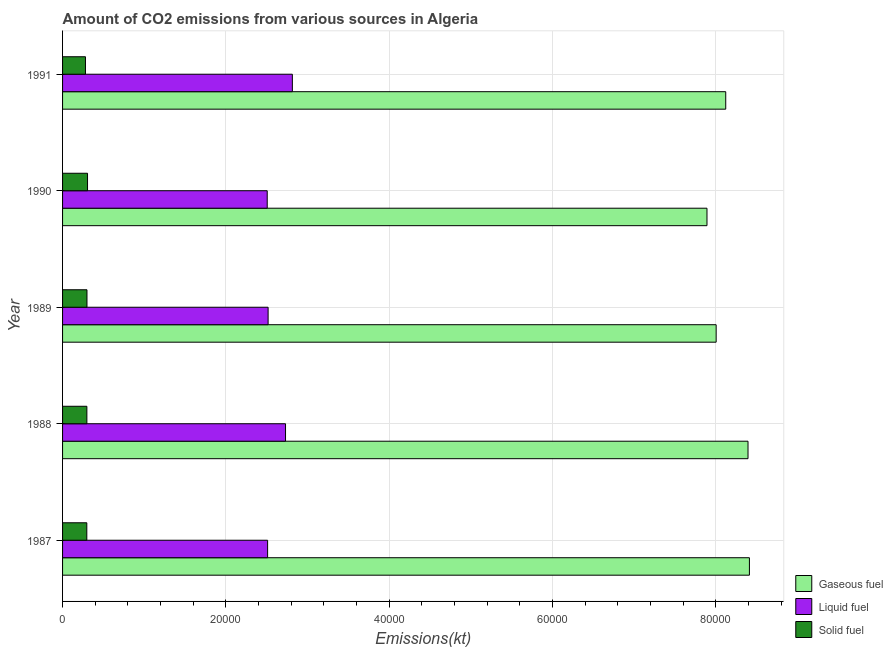How many different coloured bars are there?
Your answer should be very brief. 3. Are the number of bars per tick equal to the number of legend labels?
Offer a very short reply. Yes. How many bars are there on the 1st tick from the top?
Provide a succinct answer. 3. What is the label of the 2nd group of bars from the top?
Provide a short and direct response. 1990. What is the amount of co2 emissions from gaseous fuel in 1987?
Your answer should be very brief. 8.41e+04. Across all years, what is the maximum amount of co2 emissions from gaseous fuel?
Offer a very short reply. 8.41e+04. Across all years, what is the minimum amount of co2 emissions from liquid fuel?
Your answer should be compact. 2.51e+04. In which year was the amount of co2 emissions from liquid fuel maximum?
Ensure brevity in your answer.  1991. What is the total amount of co2 emissions from gaseous fuel in the graph?
Your response must be concise. 4.08e+05. What is the difference between the amount of co2 emissions from gaseous fuel in 1987 and that in 1988?
Offer a very short reply. 172.35. What is the difference between the amount of co2 emissions from gaseous fuel in 1991 and the amount of co2 emissions from liquid fuel in 1989?
Keep it short and to the point. 5.60e+04. What is the average amount of co2 emissions from gaseous fuel per year?
Your response must be concise. 8.17e+04. In the year 1990, what is the difference between the amount of co2 emissions from solid fuel and amount of co2 emissions from liquid fuel?
Give a very brief answer. -2.20e+04. What is the ratio of the amount of co2 emissions from solid fuel in 1987 to that in 1990?
Your answer should be very brief. 0.97. Is the amount of co2 emissions from solid fuel in 1989 less than that in 1991?
Offer a very short reply. No. Is the difference between the amount of co2 emissions from solid fuel in 1987 and 1991 greater than the difference between the amount of co2 emissions from gaseous fuel in 1987 and 1991?
Give a very brief answer. No. What is the difference between the highest and the second highest amount of co2 emissions from solid fuel?
Your answer should be very brief. 69.67. What is the difference between the highest and the lowest amount of co2 emissions from liquid fuel?
Keep it short and to the point. 3080.28. Is the sum of the amount of co2 emissions from liquid fuel in 1987 and 1989 greater than the maximum amount of co2 emissions from solid fuel across all years?
Your answer should be very brief. Yes. What does the 3rd bar from the top in 1989 represents?
Make the answer very short. Gaseous fuel. What does the 3rd bar from the bottom in 1988 represents?
Give a very brief answer. Solid fuel. Is it the case that in every year, the sum of the amount of co2 emissions from gaseous fuel and amount of co2 emissions from liquid fuel is greater than the amount of co2 emissions from solid fuel?
Your answer should be very brief. Yes. Are all the bars in the graph horizontal?
Provide a succinct answer. Yes. How many legend labels are there?
Offer a very short reply. 3. How are the legend labels stacked?
Provide a succinct answer. Vertical. What is the title of the graph?
Keep it short and to the point. Amount of CO2 emissions from various sources in Algeria. Does "Tertiary education" appear as one of the legend labels in the graph?
Ensure brevity in your answer.  No. What is the label or title of the X-axis?
Offer a very short reply. Emissions(kt). What is the label or title of the Y-axis?
Your response must be concise. Year. What is the Emissions(kt) in Gaseous fuel in 1987?
Ensure brevity in your answer.  8.41e+04. What is the Emissions(kt) of Liquid fuel in 1987?
Ensure brevity in your answer.  2.51e+04. What is the Emissions(kt) in Solid fuel in 1987?
Provide a succinct answer. 2970.27. What is the Emissions(kt) in Gaseous fuel in 1988?
Give a very brief answer. 8.39e+04. What is the Emissions(kt) in Liquid fuel in 1988?
Make the answer very short. 2.73e+04. What is the Emissions(kt) of Solid fuel in 1988?
Give a very brief answer. 2977.6. What is the Emissions(kt) in Gaseous fuel in 1989?
Offer a terse response. 8.00e+04. What is the Emissions(kt) of Liquid fuel in 1989?
Your answer should be very brief. 2.52e+04. What is the Emissions(kt) in Solid fuel in 1989?
Keep it short and to the point. 2988.61. What is the Emissions(kt) in Gaseous fuel in 1990?
Give a very brief answer. 7.89e+04. What is the Emissions(kt) in Liquid fuel in 1990?
Ensure brevity in your answer.  2.51e+04. What is the Emissions(kt) in Solid fuel in 1990?
Your answer should be compact. 3058.28. What is the Emissions(kt) in Gaseous fuel in 1991?
Your response must be concise. 8.12e+04. What is the Emissions(kt) in Liquid fuel in 1991?
Provide a short and direct response. 2.81e+04. What is the Emissions(kt) of Solid fuel in 1991?
Keep it short and to the point. 2805.26. Across all years, what is the maximum Emissions(kt) of Gaseous fuel?
Offer a terse response. 8.41e+04. Across all years, what is the maximum Emissions(kt) of Liquid fuel?
Your answer should be compact. 2.81e+04. Across all years, what is the maximum Emissions(kt) in Solid fuel?
Make the answer very short. 3058.28. Across all years, what is the minimum Emissions(kt) in Gaseous fuel?
Your answer should be very brief. 7.89e+04. Across all years, what is the minimum Emissions(kt) in Liquid fuel?
Give a very brief answer. 2.51e+04. Across all years, what is the minimum Emissions(kt) in Solid fuel?
Offer a terse response. 2805.26. What is the total Emissions(kt) in Gaseous fuel in the graph?
Offer a very short reply. 4.08e+05. What is the total Emissions(kt) of Liquid fuel in the graph?
Offer a terse response. 1.31e+05. What is the total Emissions(kt) of Solid fuel in the graph?
Provide a short and direct response. 1.48e+04. What is the difference between the Emissions(kt) of Gaseous fuel in 1987 and that in 1988?
Ensure brevity in your answer.  172.35. What is the difference between the Emissions(kt) of Liquid fuel in 1987 and that in 1988?
Your answer should be compact. -2196.53. What is the difference between the Emissions(kt) in Solid fuel in 1987 and that in 1988?
Provide a succinct answer. -7.33. What is the difference between the Emissions(kt) in Gaseous fuel in 1987 and that in 1989?
Make the answer very short. 4074.04. What is the difference between the Emissions(kt) in Liquid fuel in 1987 and that in 1989?
Offer a very short reply. -62.34. What is the difference between the Emissions(kt) in Solid fuel in 1987 and that in 1989?
Your response must be concise. -18.34. What is the difference between the Emissions(kt) in Gaseous fuel in 1987 and that in 1990?
Ensure brevity in your answer.  5196.14. What is the difference between the Emissions(kt) of Liquid fuel in 1987 and that in 1990?
Keep it short and to the point. 47.67. What is the difference between the Emissions(kt) of Solid fuel in 1987 and that in 1990?
Keep it short and to the point. -88.01. What is the difference between the Emissions(kt) in Gaseous fuel in 1987 and that in 1991?
Your response must be concise. 2900.6. What is the difference between the Emissions(kt) of Liquid fuel in 1987 and that in 1991?
Keep it short and to the point. -3032.61. What is the difference between the Emissions(kt) of Solid fuel in 1987 and that in 1991?
Offer a terse response. 165.01. What is the difference between the Emissions(kt) in Gaseous fuel in 1988 and that in 1989?
Your answer should be compact. 3901.69. What is the difference between the Emissions(kt) in Liquid fuel in 1988 and that in 1989?
Your answer should be very brief. 2134.19. What is the difference between the Emissions(kt) in Solid fuel in 1988 and that in 1989?
Your response must be concise. -11. What is the difference between the Emissions(kt) of Gaseous fuel in 1988 and that in 1990?
Provide a short and direct response. 5023.79. What is the difference between the Emissions(kt) in Liquid fuel in 1988 and that in 1990?
Provide a succinct answer. 2244.2. What is the difference between the Emissions(kt) of Solid fuel in 1988 and that in 1990?
Your answer should be very brief. -80.67. What is the difference between the Emissions(kt) in Gaseous fuel in 1988 and that in 1991?
Ensure brevity in your answer.  2728.25. What is the difference between the Emissions(kt) of Liquid fuel in 1988 and that in 1991?
Give a very brief answer. -836.08. What is the difference between the Emissions(kt) of Solid fuel in 1988 and that in 1991?
Offer a terse response. 172.35. What is the difference between the Emissions(kt) in Gaseous fuel in 1989 and that in 1990?
Provide a short and direct response. 1122.1. What is the difference between the Emissions(kt) in Liquid fuel in 1989 and that in 1990?
Your answer should be very brief. 110.01. What is the difference between the Emissions(kt) in Solid fuel in 1989 and that in 1990?
Provide a succinct answer. -69.67. What is the difference between the Emissions(kt) of Gaseous fuel in 1989 and that in 1991?
Your response must be concise. -1173.44. What is the difference between the Emissions(kt) in Liquid fuel in 1989 and that in 1991?
Your response must be concise. -2970.27. What is the difference between the Emissions(kt) in Solid fuel in 1989 and that in 1991?
Ensure brevity in your answer.  183.35. What is the difference between the Emissions(kt) of Gaseous fuel in 1990 and that in 1991?
Your answer should be compact. -2295.54. What is the difference between the Emissions(kt) of Liquid fuel in 1990 and that in 1991?
Your answer should be very brief. -3080.28. What is the difference between the Emissions(kt) in Solid fuel in 1990 and that in 1991?
Provide a succinct answer. 253.02. What is the difference between the Emissions(kt) of Gaseous fuel in 1987 and the Emissions(kt) of Liquid fuel in 1988?
Offer a very short reply. 5.68e+04. What is the difference between the Emissions(kt) of Gaseous fuel in 1987 and the Emissions(kt) of Solid fuel in 1988?
Make the answer very short. 8.11e+04. What is the difference between the Emissions(kt) in Liquid fuel in 1987 and the Emissions(kt) in Solid fuel in 1988?
Your response must be concise. 2.21e+04. What is the difference between the Emissions(kt) in Gaseous fuel in 1987 and the Emissions(kt) in Liquid fuel in 1989?
Give a very brief answer. 5.89e+04. What is the difference between the Emissions(kt) of Gaseous fuel in 1987 and the Emissions(kt) of Solid fuel in 1989?
Offer a terse response. 8.11e+04. What is the difference between the Emissions(kt) of Liquid fuel in 1987 and the Emissions(kt) of Solid fuel in 1989?
Your answer should be compact. 2.21e+04. What is the difference between the Emissions(kt) in Gaseous fuel in 1987 and the Emissions(kt) in Liquid fuel in 1990?
Keep it short and to the point. 5.91e+04. What is the difference between the Emissions(kt) of Gaseous fuel in 1987 and the Emissions(kt) of Solid fuel in 1990?
Keep it short and to the point. 8.11e+04. What is the difference between the Emissions(kt) in Liquid fuel in 1987 and the Emissions(kt) in Solid fuel in 1990?
Offer a terse response. 2.21e+04. What is the difference between the Emissions(kt) in Gaseous fuel in 1987 and the Emissions(kt) in Liquid fuel in 1991?
Offer a terse response. 5.60e+04. What is the difference between the Emissions(kt) in Gaseous fuel in 1987 and the Emissions(kt) in Solid fuel in 1991?
Your answer should be very brief. 8.13e+04. What is the difference between the Emissions(kt) in Liquid fuel in 1987 and the Emissions(kt) in Solid fuel in 1991?
Ensure brevity in your answer.  2.23e+04. What is the difference between the Emissions(kt) in Gaseous fuel in 1988 and the Emissions(kt) in Liquid fuel in 1989?
Give a very brief answer. 5.88e+04. What is the difference between the Emissions(kt) in Gaseous fuel in 1988 and the Emissions(kt) in Solid fuel in 1989?
Offer a terse response. 8.10e+04. What is the difference between the Emissions(kt) of Liquid fuel in 1988 and the Emissions(kt) of Solid fuel in 1989?
Provide a short and direct response. 2.43e+04. What is the difference between the Emissions(kt) in Gaseous fuel in 1988 and the Emissions(kt) in Liquid fuel in 1990?
Offer a very short reply. 5.89e+04. What is the difference between the Emissions(kt) in Gaseous fuel in 1988 and the Emissions(kt) in Solid fuel in 1990?
Give a very brief answer. 8.09e+04. What is the difference between the Emissions(kt) of Liquid fuel in 1988 and the Emissions(kt) of Solid fuel in 1990?
Your response must be concise. 2.42e+04. What is the difference between the Emissions(kt) of Gaseous fuel in 1988 and the Emissions(kt) of Liquid fuel in 1991?
Provide a short and direct response. 5.58e+04. What is the difference between the Emissions(kt) of Gaseous fuel in 1988 and the Emissions(kt) of Solid fuel in 1991?
Give a very brief answer. 8.11e+04. What is the difference between the Emissions(kt) in Liquid fuel in 1988 and the Emissions(kt) in Solid fuel in 1991?
Offer a terse response. 2.45e+04. What is the difference between the Emissions(kt) of Gaseous fuel in 1989 and the Emissions(kt) of Liquid fuel in 1990?
Your answer should be very brief. 5.50e+04. What is the difference between the Emissions(kt) in Gaseous fuel in 1989 and the Emissions(kt) in Solid fuel in 1990?
Ensure brevity in your answer.  7.70e+04. What is the difference between the Emissions(kt) in Liquid fuel in 1989 and the Emissions(kt) in Solid fuel in 1990?
Keep it short and to the point. 2.21e+04. What is the difference between the Emissions(kt) in Gaseous fuel in 1989 and the Emissions(kt) in Liquid fuel in 1991?
Your response must be concise. 5.19e+04. What is the difference between the Emissions(kt) in Gaseous fuel in 1989 and the Emissions(kt) in Solid fuel in 1991?
Your answer should be compact. 7.72e+04. What is the difference between the Emissions(kt) in Liquid fuel in 1989 and the Emissions(kt) in Solid fuel in 1991?
Keep it short and to the point. 2.24e+04. What is the difference between the Emissions(kt) of Gaseous fuel in 1990 and the Emissions(kt) of Liquid fuel in 1991?
Offer a very short reply. 5.08e+04. What is the difference between the Emissions(kt) of Gaseous fuel in 1990 and the Emissions(kt) of Solid fuel in 1991?
Offer a very short reply. 7.61e+04. What is the difference between the Emissions(kt) in Liquid fuel in 1990 and the Emissions(kt) in Solid fuel in 1991?
Provide a short and direct response. 2.23e+04. What is the average Emissions(kt) of Gaseous fuel per year?
Offer a terse response. 8.17e+04. What is the average Emissions(kt) in Liquid fuel per year?
Your answer should be very brief. 2.62e+04. What is the average Emissions(kt) of Solid fuel per year?
Keep it short and to the point. 2960. In the year 1987, what is the difference between the Emissions(kt) in Gaseous fuel and Emissions(kt) in Liquid fuel?
Offer a terse response. 5.90e+04. In the year 1987, what is the difference between the Emissions(kt) of Gaseous fuel and Emissions(kt) of Solid fuel?
Offer a terse response. 8.12e+04. In the year 1987, what is the difference between the Emissions(kt) of Liquid fuel and Emissions(kt) of Solid fuel?
Offer a terse response. 2.21e+04. In the year 1988, what is the difference between the Emissions(kt) in Gaseous fuel and Emissions(kt) in Liquid fuel?
Your answer should be very brief. 5.66e+04. In the year 1988, what is the difference between the Emissions(kt) in Gaseous fuel and Emissions(kt) in Solid fuel?
Your response must be concise. 8.10e+04. In the year 1988, what is the difference between the Emissions(kt) in Liquid fuel and Emissions(kt) in Solid fuel?
Your answer should be compact. 2.43e+04. In the year 1989, what is the difference between the Emissions(kt) of Gaseous fuel and Emissions(kt) of Liquid fuel?
Your answer should be compact. 5.49e+04. In the year 1989, what is the difference between the Emissions(kt) of Gaseous fuel and Emissions(kt) of Solid fuel?
Offer a terse response. 7.71e+04. In the year 1989, what is the difference between the Emissions(kt) in Liquid fuel and Emissions(kt) in Solid fuel?
Ensure brevity in your answer.  2.22e+04. In the year 1990, what is the difference between the Emissions(kt) of Gaseous fuel and Emissions(kt) of Liquid fuel?
Ensure brevity in your answer.  5.39e+04. In the year 1990, what is the difference between the Emissions(kt) of Gaseous fuel and Emissions(kt) of Solid fuel?
Ensure brevity in your answer.  7.59e+04. In the year 1990, what is the difference between the Emissions(kt) in Liquid fuel and Emissions(kt) in Solid fuel?
Offer a very short reply. 2.20e+04. In the year 1991, what is the difference between the Emissions(kt) of Gaseous fuel and Emissions(kt) of Liquid fuel?
Provide a succinct answer. 5.31e+04. In the year 1991, what is the difference between the Emissions(kt) in Gaseous fuel and Emissions(kt) in Solid fuel?
Offer a terse response. 7.84e+04. In the year 1991, what is the difference between the Emissions(kt) in Liquid fuel and Emissions(kt) in Solid fuel?
Your response must be concise. 2.53e+04. What is the ratio of the Emissions(kt) in Gaseous fuel in 1987 to that in 1988?
Give a very brief answer. 1. What is the ratio of the Emissions(kt) of Liquid fuel in 1987 to that in 1988?
Provide a short and direct response. 0.92. What is the ratio of the Emissions(kt) in Solid fuel in 1987 to that in 1988?
Offer a very short reply. 1. What is the ratio of the Emissions(kt) in Gaseous fuel in 1987 to that in 1989?
Make the answer very short. 1.05. What is the ratio of the Emissions(kt) of Liquid fuel in 1987 to that in 1989?
Offer a very short reply. 1. What is the ratio of the Emissions(kt) of Gaseous fuel in 1987 to that in 1990?
Your response must be concise. 1.07. What is the ratio of the Emissions(kt) in Liquid fuel in 1987 to that in 1990?
Your response must be concise. 1. What is the ratio of the Emissions(kt) in Solid fuel in 1987 to that in 1990?
Your answer should be very brief. 0.97. What is the ratio of the Emissions(kt) of Gaseous fuel in 1987 to that in 1991?
Your answer should be very brief. 1.04. What is the ratio of the Emissions(kt) of Liquid fuel in 1987 to that in 1991?
Offer a very short reply. 0.89. What is the ratio of the Emissions(kt) in Solid fuel in 1987 to that in 1991?
Offer a very short reply. 1.06. What is the ratio of the Emissions(kt) in Gaseous fuel in 1988 to that in 1989?
Offer a terse response. 1.05. What is the ratio of the Emissions(kt) in Liquid fuel in 1988 to that in 1989?
Make the answer very short. 1.08. What is the ratio of the Emissions(kt) in Gaseous fuel in 1988 to that in 1990?
Offer a very short reply. 1.06. What is the ratio of the Emissions(kt) in Liquid fuel in 1988 to that in 1990?
Your answer should be compact. 1.09. What is the ratio of the Emissions(kt) in Solid fuel in 1988 to that in 1990?
Your answer should be compact. 0.97. What is the ratio of the Emissions(kt) in Gaseous fuel in 1988 to that in 1991?
Provide a succinct answer. 1.03. What is the ratio of the Emissions(kt) in Liquid fuel in 1988 to that in 1991?
Your answer should be very brief. 0.97. What is the ratio of the Emissions(kt) in Solid fuel in 1988 to that in 1991?
Provide a succinct answer. 1.06. What is the ratio of the Emissions(kt) of Gaseous fuel in 1989 to that in 1990?
Your answer should be very brief. 1.01. What is the ratio of the Emissions(kt) of Liquid fuel in 1989 to that in 1990?
Your response must be concise. 1. What is the ratio of the Emissions(kt) of Solid fuel in 1989 to that in 1990?
Give a very brief answer. 0.98. What is the ratio of the Emissions(kt) in Gaseous fuel in 1989 to that in 1991?
Your answer should be very brief. 0.99. What is the ratio of the Emissions(kt) in Liquid fuel in 1989 to that in 1991?
Your answer should be compact. 0.89. What is the ratio of the Emissions(kt) in Solid fuel in 1989 to that in 1991?
Ensure brevity in your answer.  1.07. What is the ratio of the Emissions(kt) of Gaseous fuel in 1990 to that in 1991?
Make the answer very short. 0.97. What is the ratio of the Emissions(kt) of Liquid fuel in 1990 to that in 1991?
Give a very brief answer. 0.89. What is the ratio of the Emissions(kt) of Solid fuel in 1990 to that in 1991?
Ensure brevity in your answer.  1.09. What is the difference between the highest and the second highest Emissions(kt) of Gaseous fuel?
Make the answer very short. 172.35. What is the difference between the highest and the second highest Emissions(kt) in Liquid fuel?
Ensure brevity in your answer.  836.08. What is the difference between the highest and the second highest Emissions(kt) of Solid fuel?
Your answer should be very brief. 69.67. What is the difference between the highest and the lowest Emissions(kt) of Gaseous fuel?
Keep it short and to the point. 5196.14. What is the difference between the highest and the lowest Emissions(kt) in Liquid fuel?
Offer a terse response. 3080.28. What is the difference between the highest and the lowest Emissions(kt) of Solid fuel?
Provide a short and direct response. 253.02. 